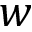Convert formula to latex. <formula><loc_0><loc_0><loc_500><loc_500>w</formula> 